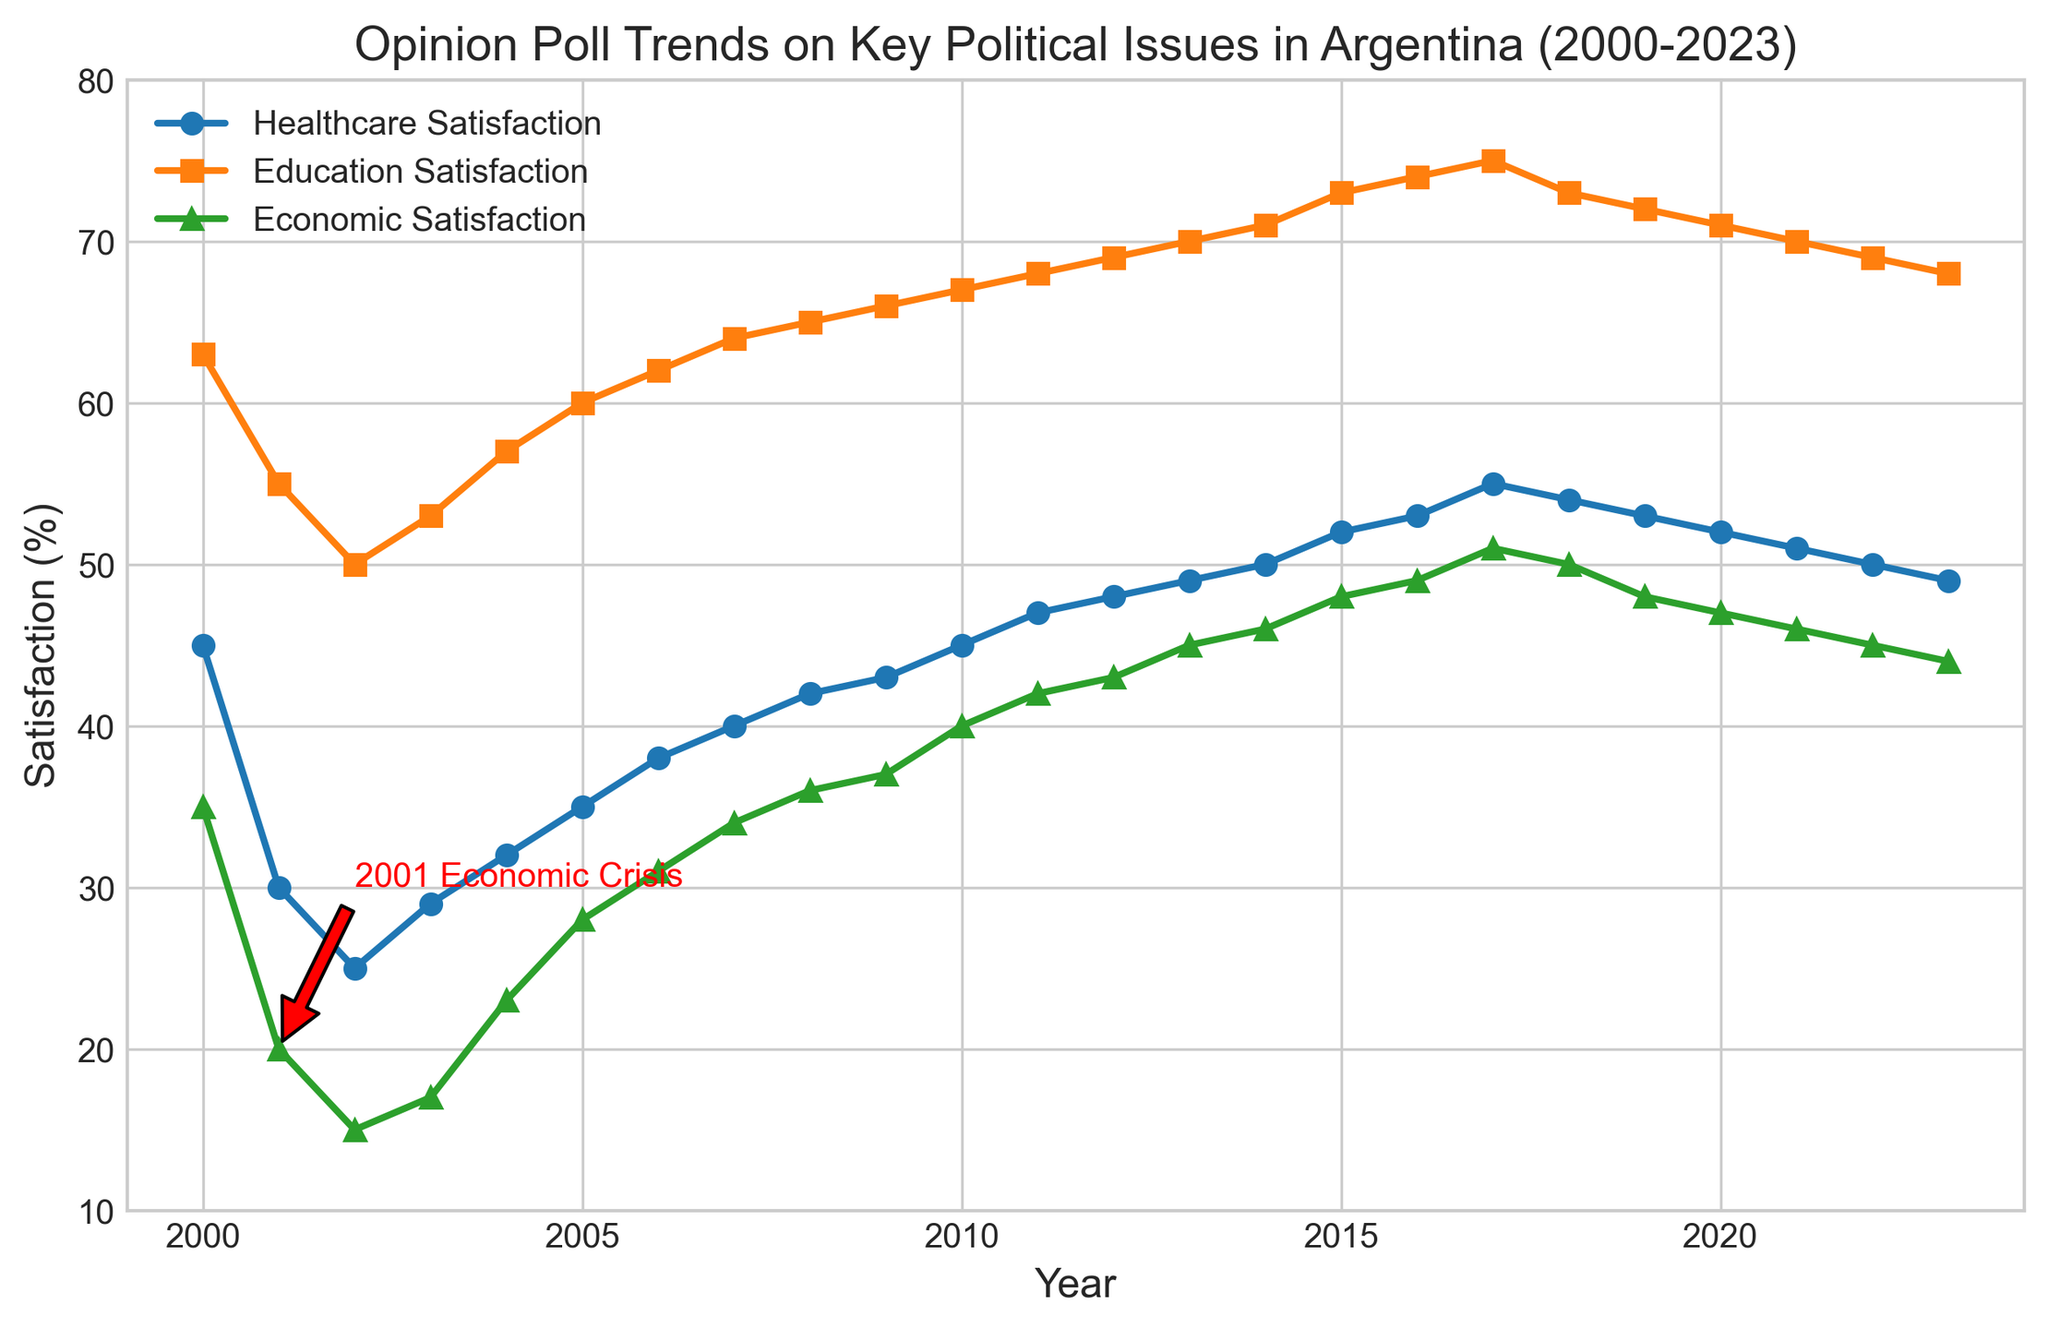What's the trend in Healthcare Satisfaction from 2000 to 2023? By observing the line representing Healthcare Satisfaction, it starts at 45% in 2000, declines sharply until 2002, and then shows a general upward trend thereafter, peaking around 2017 and slightly declining towards 2023.
Answer: Upward trend with slight decline at the end Which year had the lowest Economic Satisfaction and why might this be significant? The annotation points out the 2001 Economic Crisis; the Economic Satisfaction line reaches its lowest point (15%) in 2002, immediately following this crisis.
Answer: 2002 Compare the trends in Education Satisfaction and Healthcare Satisfaction between 2000 and 2023. Both lines show an increasing trend over the years, but Education Satisfaction starts higher and increases more steadily. Healthcare Satisfaction starts lower and shows a more noticeable rise, particularly from 2002 onwards.
Answer: Both increase, Education starts higher and increases more steadily What is the difference in Economic Satisfaction between 2001 and 2003? In 2001, Economic Satisfaction is 20%, and in 2003, it is 17%. The difference is 20% - 17% = 3%.
Answer: 3% How did the levels of satisfaction with Healthcare, Education, and the Economy respond immediately following the 2001 Economic Crisis (2002)? Healthcare Satisfaction dropped to 25%, Education Satisfaction to 50%, and Economic Satisfaction to 15%, illustrating the substantial impact of the crisis on public opinion.
Answer: All dropped significantly In which year did Education Satisfaction reach its highest point? By observing the line representing Education Satisfaction, its highest point is recorded in 2017 at 75%.
Answer: 2017 How did the trend in Economic Satisfaction change between 2017 and 2023? From 2017 to 2023, the Economic Satisfaction declines from 51% to 44%, indicating a downward trend.
Answer: Declines Which satisfaction category has the smallest variability from 2000 to 2023? By comparing the lines visually, Education Satisfaction shows the smallest variability, following a steadier and less fluctuating incline.
Answer: Education Satisfaction Was there any year where all three satisfaction categories had increased from the previous year? By examining the trends, 2005 shows an increase in Healthcare (from 32% to 35%), Education (from 57% to 60%), and Economic Satisfaction (from 23% to 28%).
Answer: 2005 Given the annotation and subsequent data, discuss how the political climate might have influenced public satisfaction with key issues. The 2001 Economic Crisis, as indicated by the annotation, caused a significant drop in public satisfaction across all categories. This reflects public sensitivity to economic and political stability, likely impacting opinions on governance and policy effectiveness.
Answer: Crisis led to significant satisfaction drops 